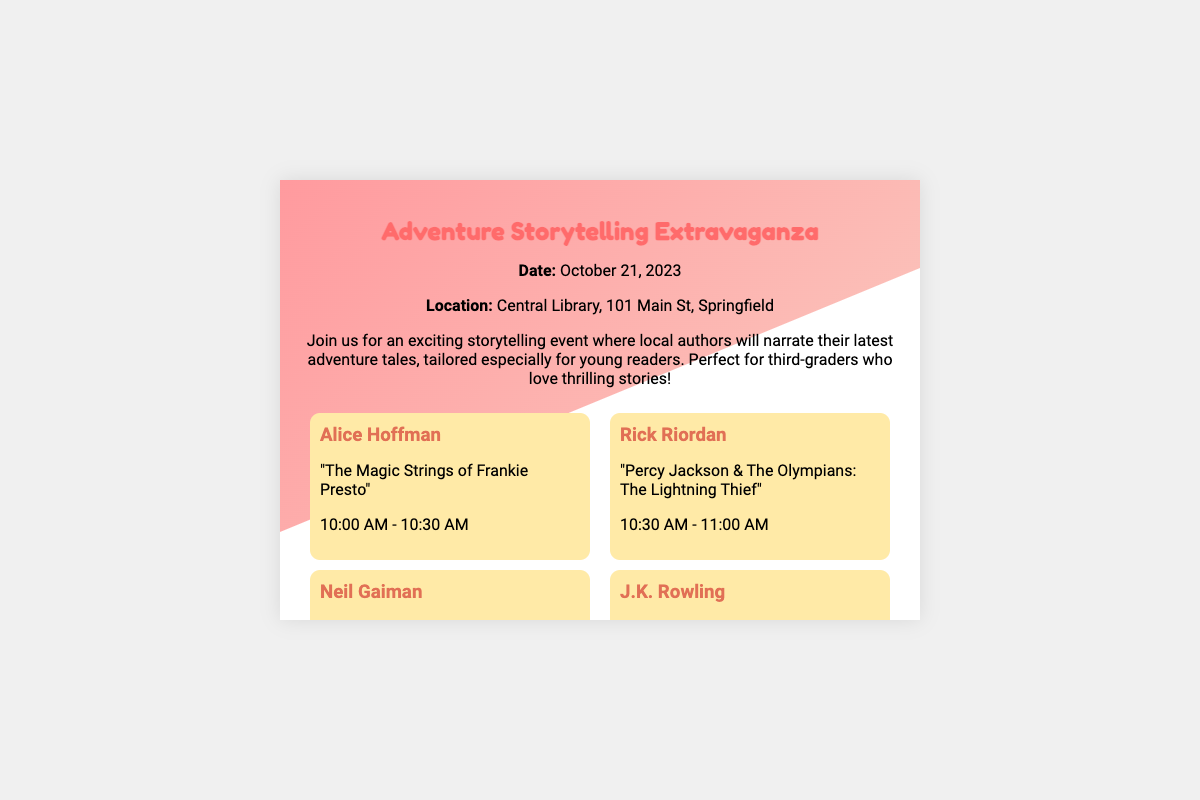What is the date of the event? The document specifies the date of the event as October 21, 2023.
Answer: October 21, 2023 Where will the event be held? The location of the event is mentioned as Central Library, 101 Main St, Springfield.
Answer: Central Library, 101 Main St, Springfield Who is narrating "Percy Jackson & The Olympians: The Lightning Thief"? The document lists Rick Riordan as the author narrating this title during the event.
Answer: Rick Riordan What time does the event featuring J.K. Rowling start? According to the schedule, J.K. Rowling's narration begins at 11:30 AM.
Answer: 11:30 AM Is there a cost for entering the event? The document clearly states that there is free entry to the event.
Answer: Free Entry 